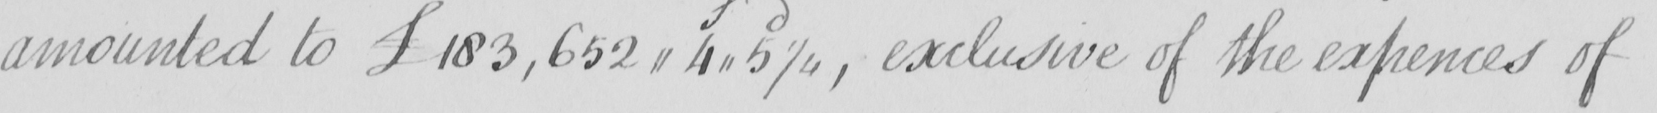Please provide the text content of this handwritten line. amounted to £183,652,,4,,5 1/4 , exclusive of the expences of 